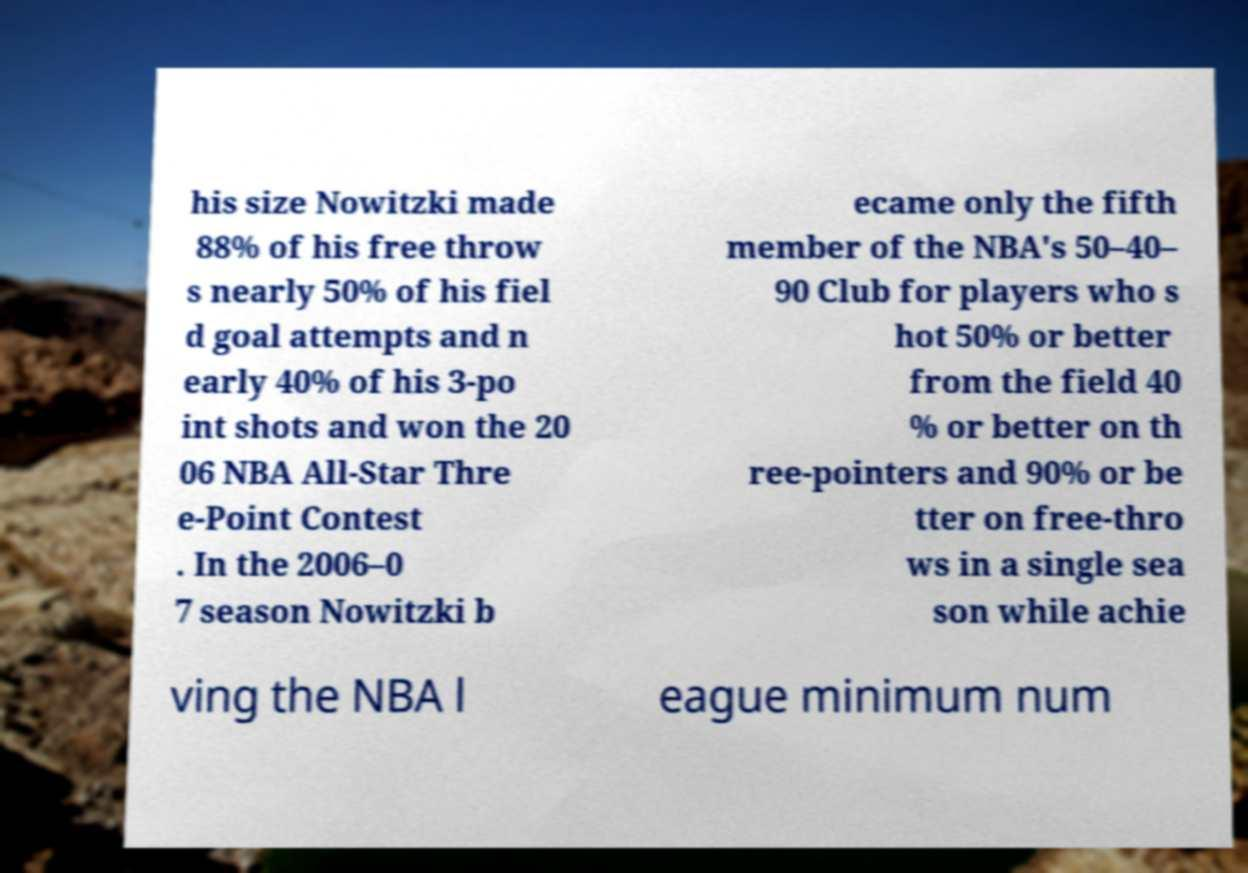Please identify and transcribe the text found in this image. his size Nowitzki made 88% of his free throw s nearly 50% of his fiel d goal attempts and n early 40% of his 3-po int shots and won the 20 06 NBA All-Star Thre e-Point Contest . In the 2006–0 7 season Nowitzki b ecame only the fifth member of the NBA's 50–40– 90 Club for players who s hot 50% or better from the field 40 % or better on th ree-pointers and 90% or be tter on free-thro ws in a single sea son while achie ving the NBA l eague minimum num 